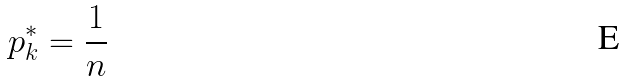<formula> <loc_0><loc_0><loc_500><loc_500>p _ { k } ^ { * } = \frac { 1 } { n }</formula> 